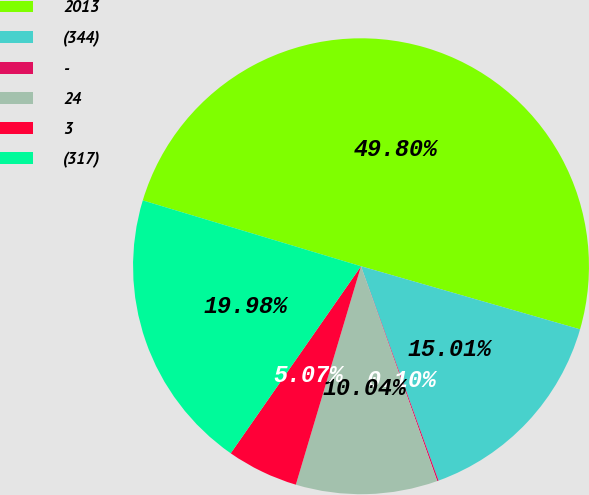Convert chart. <chart><loc_0><loc_0><loc_500><loc_500><pie_chart><fcel>2013<fcel>(344)<fcel>-<fcel>24<fcel>3<fcel>(317)<nl><fcel>49.8%<fcel>15.01%<fcel>0.1%<fcel>10.04%<fcel>5.07%<fcel>19.98%<nl></chart> 